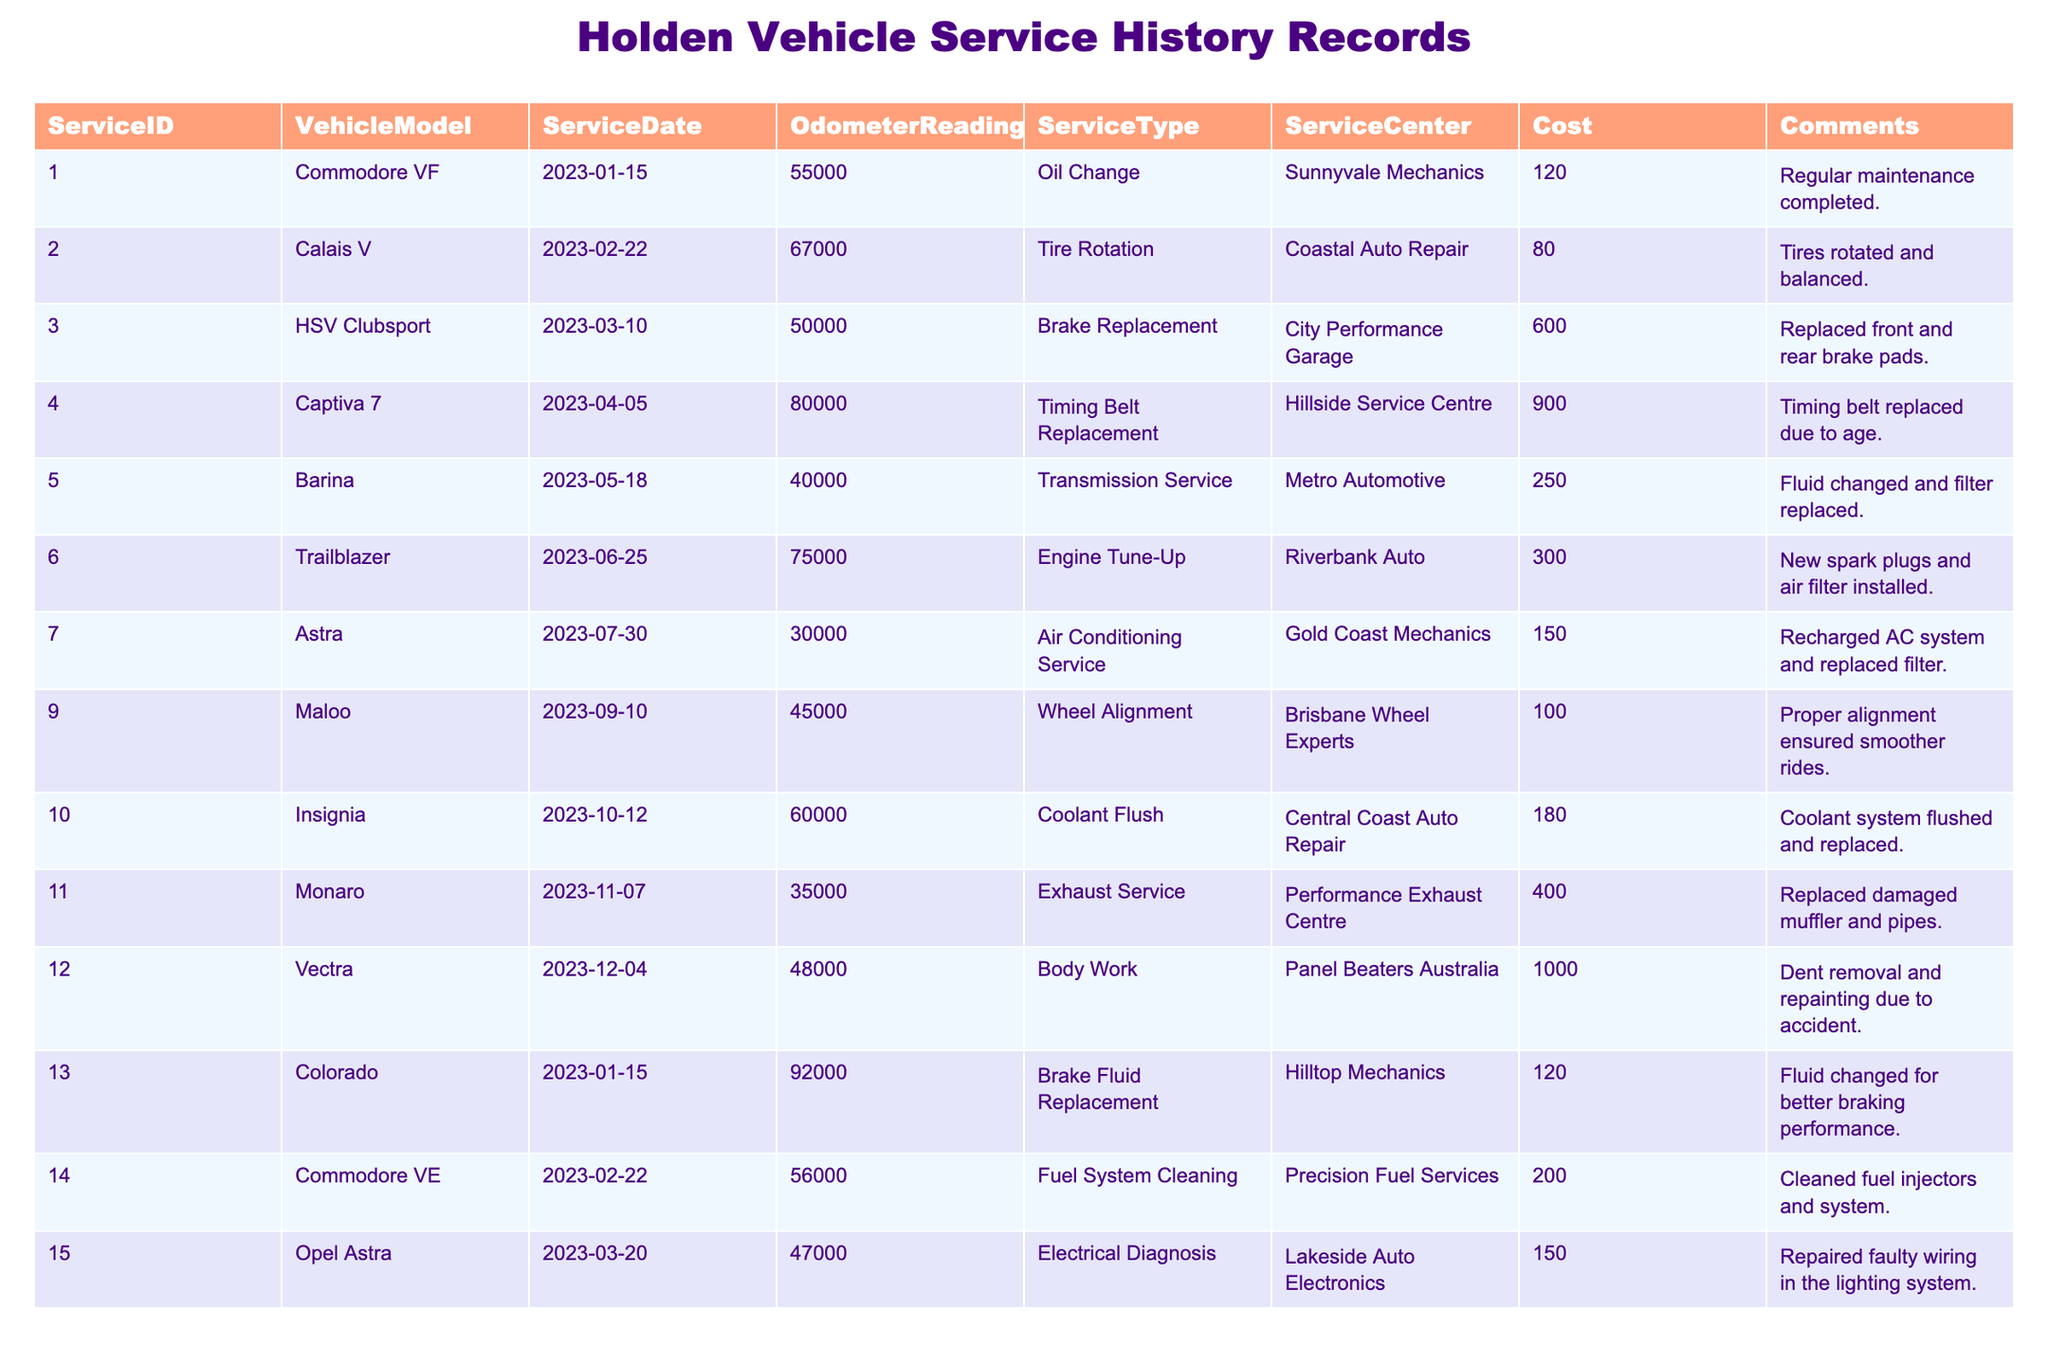What is the total cost of all services listed? To find the total cost, sum all the values in the Cost column: 120 + 80 + 600 + 900 + 250 + 300 + 150 + 100 + 180 + 400 + 1000 + 120 + 200 + 150 = 4070
Answer: 4070 How many services were performed on the Commodore models? There are two entries for Commodore: one for the VF model and one for the VE model, as noted in the VehicleModel column.
Answer: 2 Which service center had the highest total cost? Calculate the total cost per service center: Sunnyvale Mechanics (120), Coastal Auto Repair (80), City Performance Garage (600), Hillside Service Centre (900), Metro Automotive (250), Riverbank Auto (300), Gold Coast Mechanics (150), Brisbane Wheel Experts (100), Central Coast Auto Repair (180), Performance Exhaust Centre (400), Panel Beaters Australia (1000), Hilltop Mechanics (120), Precision Fuel Services (200), Lakeside Auto Electronics (150). The highest total cost is at Panel Beaters Australia with 1000.
Answer: Panel Beaters Australia What type of service had the lowest cost? Review the Cost column to find the minimum value: the lowest cost is 80, corresponding to the Tire Rotation service at Coastal Auto Repair.
Answer: Tire Rotation What model had a service performed on the earliest date? Looking at the ServiceDate column, the earliest date is 2023-01-15, which corresponds to the Commodore VF and Colorado. Both models have a service performed on that date.
Answer: Commodore VF and Colorado How many services were performed in 2023? All entries in the provided data are from the year 2023, indicating that there are 14 services performed in this year.
Answer: 14 What is the average odometer reading of all vehicles serviced? Calculate the average by summing the OdometerReading values (55000 + 67000 + 50000 + 80000 + 40000 + 75000 + 30000 + 45000 + 60000 + 35000 + 48000 + 92000 + 56000 + 47000) = 626000, and dividing by the number of entries (14) gives an average of 626000/14 = 44642.86
Answer: 44642.86 Which service type had more than one occurrence? Review the ServiceType column: Oil Change (1), Tire Rotation (1), Brake Replacement (1), Timing Belt Replacement (1), Transmission Service (1), Engine Tune-Up (1), Air Conditioning Service (1), Wheel Alignment (1), Coolant Flush (1), Exhaust Service (1), Body Work (1), Brake Fluid Replacement (1), Fuel System Cleaning (1), Electrical Diagnosis (1) indicate that all types are unique, so no service type has multiple entries.
Answer: None Was there any service related to "Brake" and what was the cost? Review the table for services related to "Brake": there are two entries. The Brake Replacement service on the HSV Clubsport cost 600 and Brake Fluid Replacement on the Colorado cost 120.
Answer: Yes, 600 and 120 